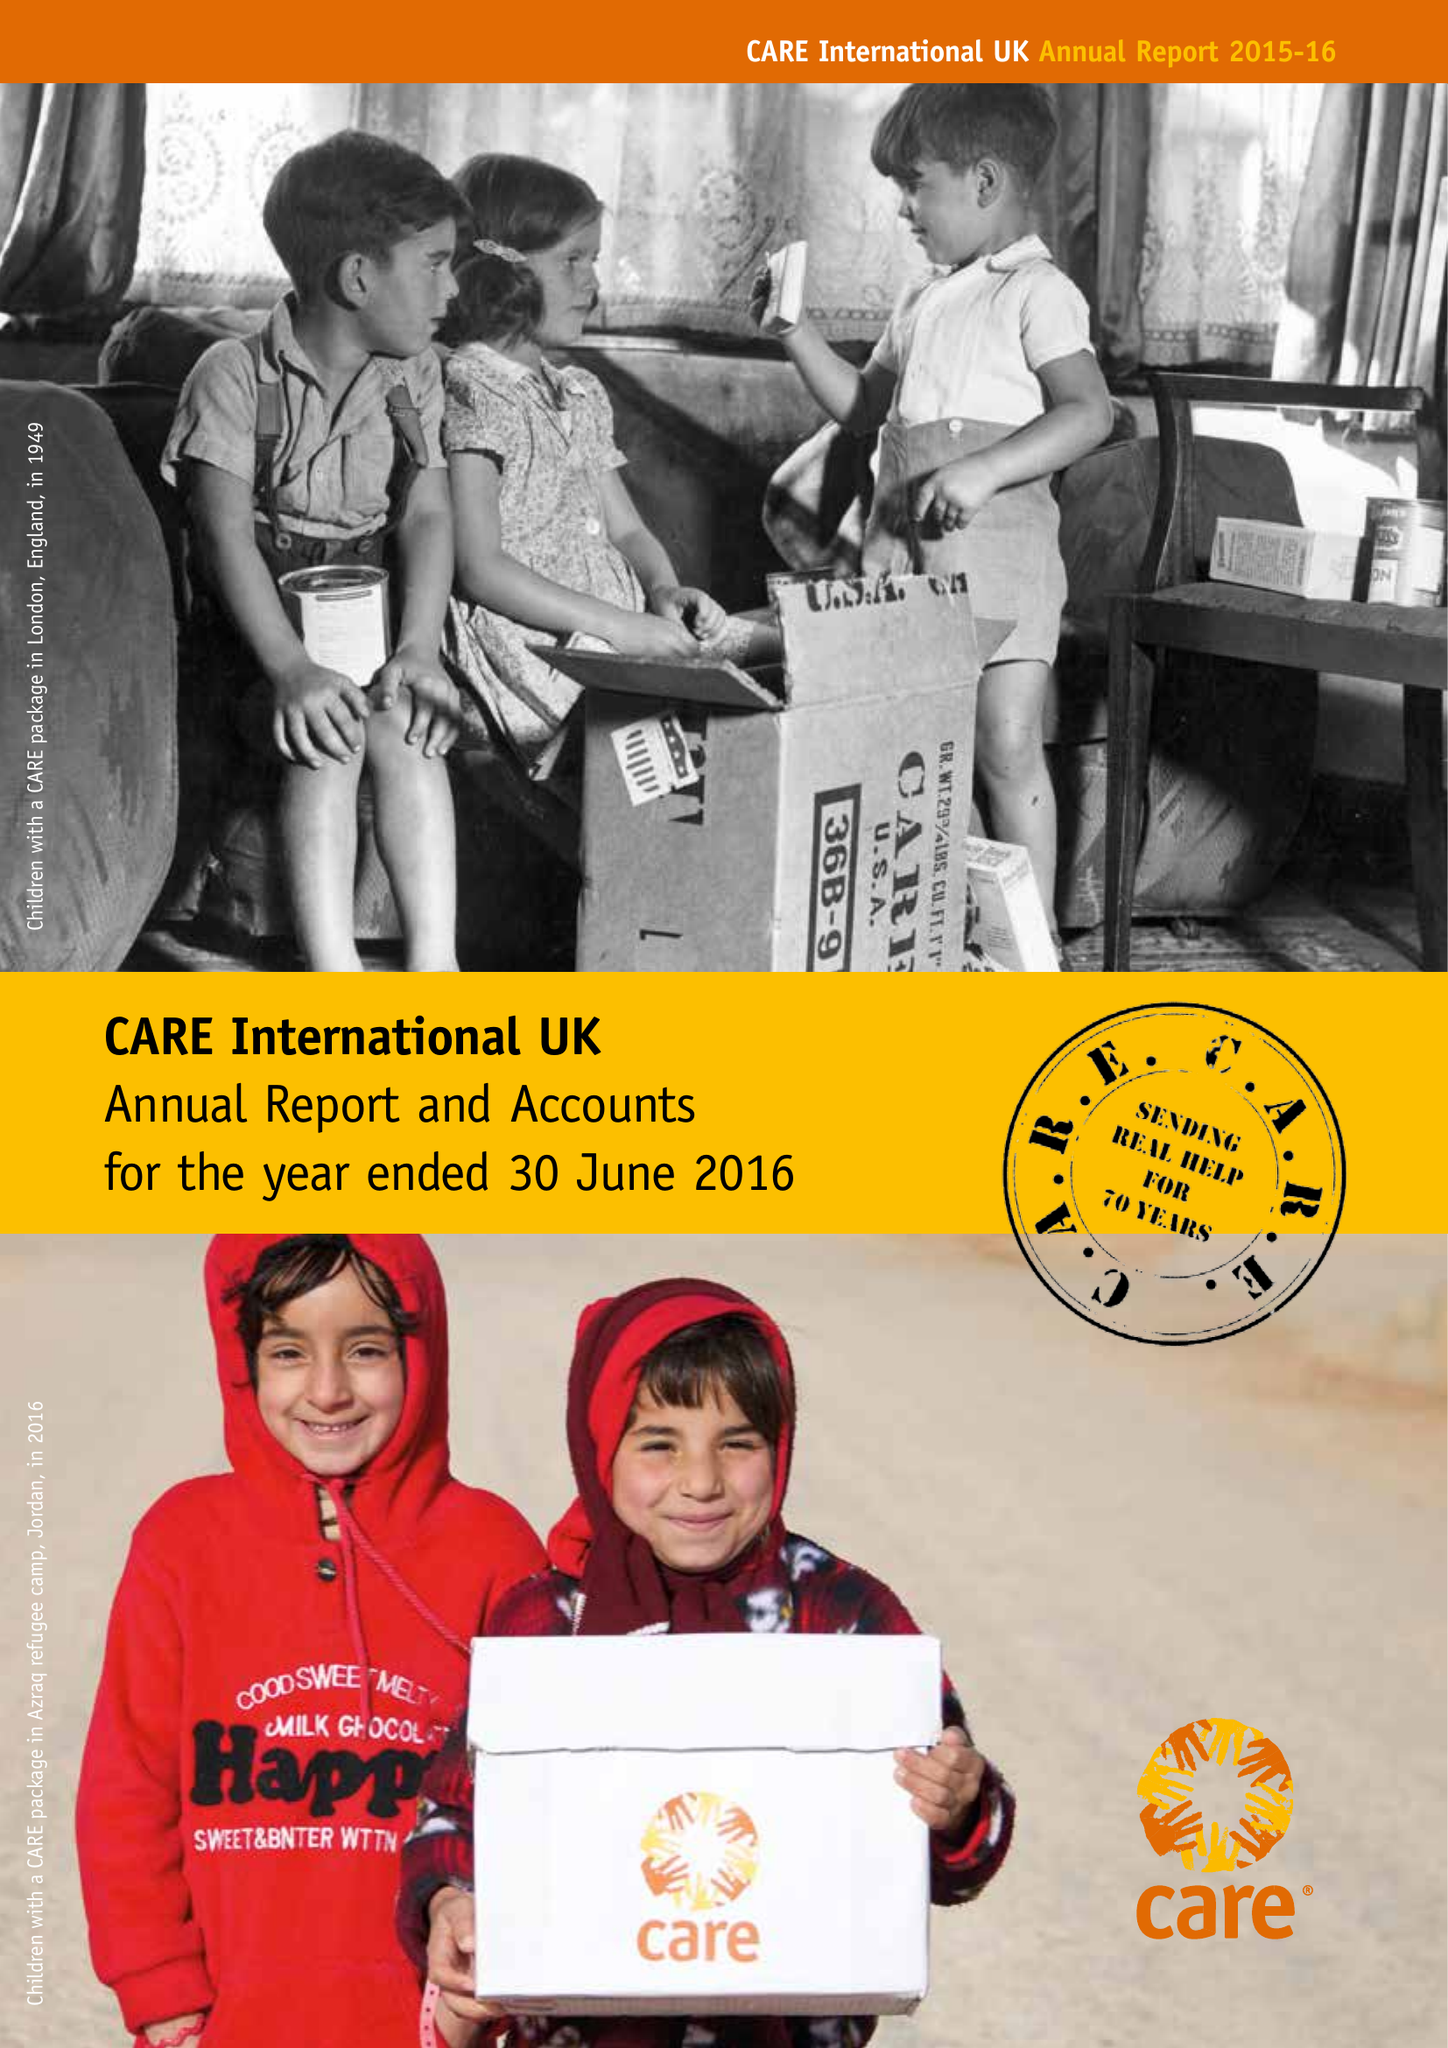What is the value for the charity_name?
Answer the question using a single word or phrase. Care International Uk 